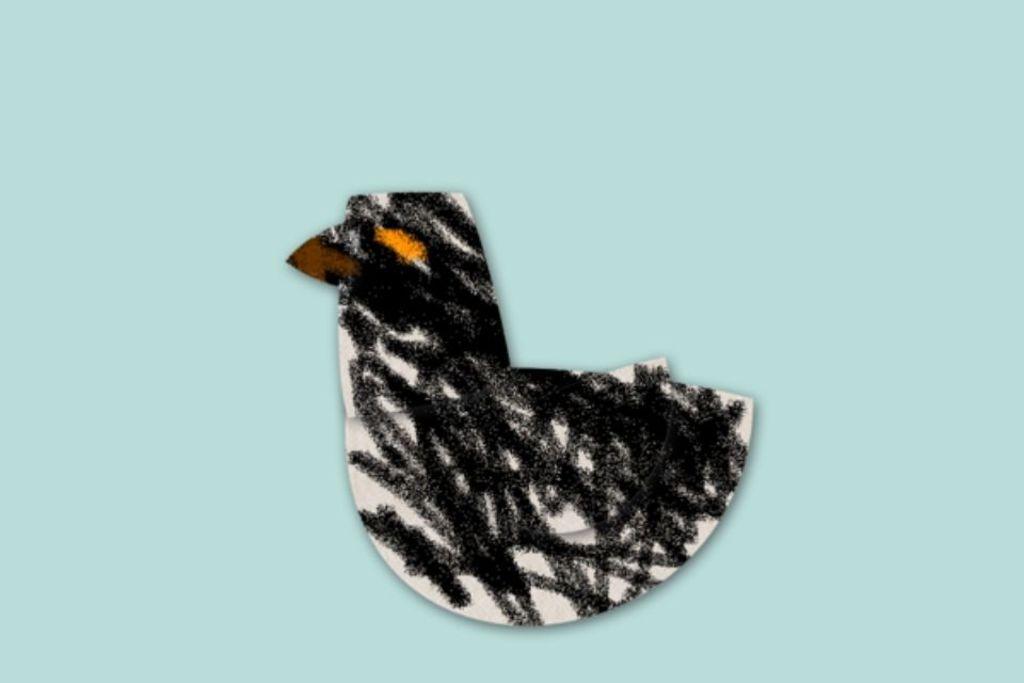In one or two sentences, can you explain what this image depicts? In this image I can see the blue colored surface on which I can see a object which is in the shape of a bird which is black, orange, brown and white in color. 